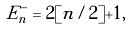<formula> <loc_0><loc_0><loc_500><loc_500>E _ { n } ^ { - } = 2 [ n / 2 ] + 1 ,</formula> 